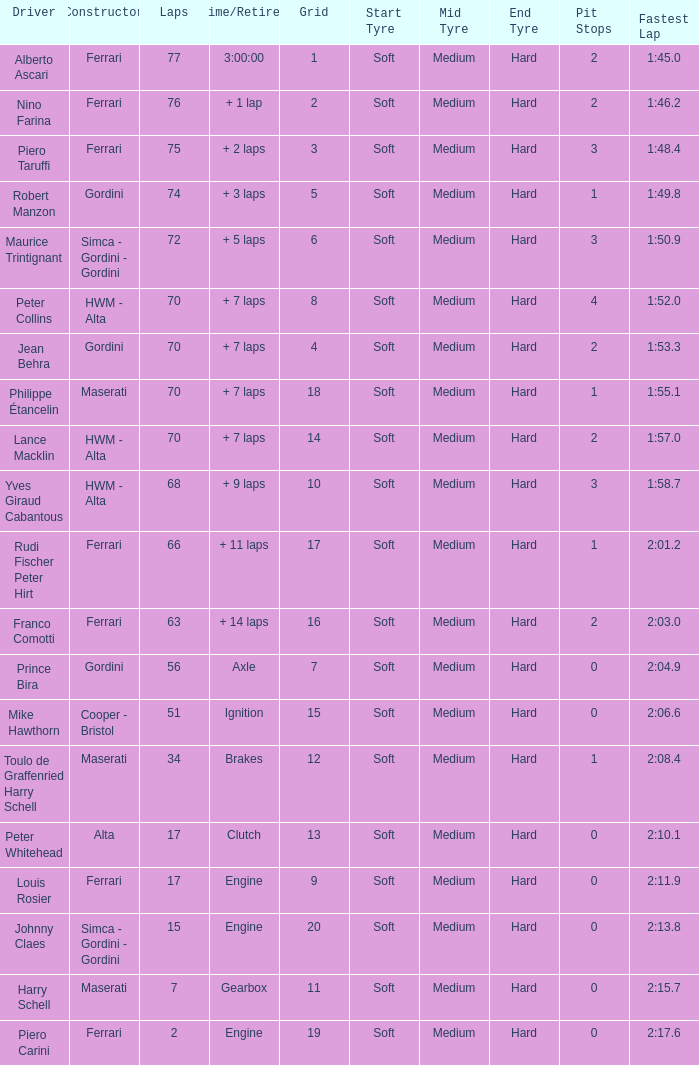How many grids for peter collins? 1.0. 